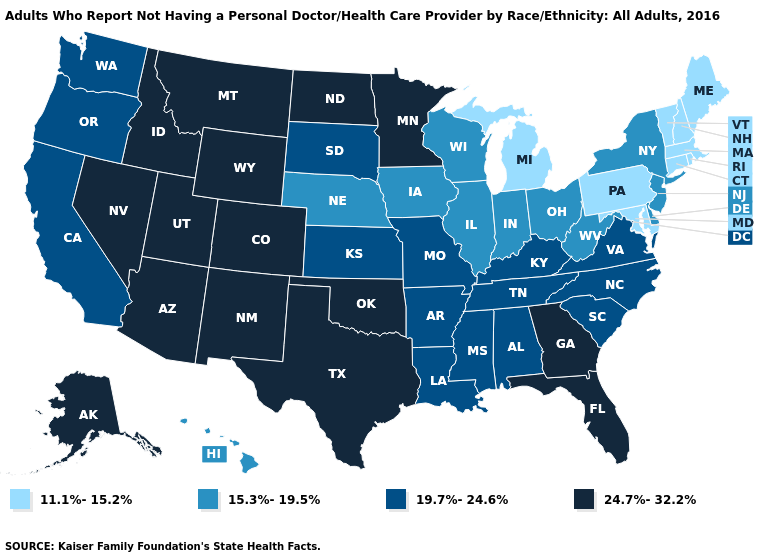Is the legend a continuous bar?
Concise answer only. No. What is the value of Texas?
Answer briefly. 24.7%-32.2%. Does Louisiana have the same value as North Carolina?
Keep it brief. Yes. What is the value of Michigan?
Quick response, please. 11.1%-15.2%. Does the map have missing data?
Quick response, please. No. What is the highest value in the MidWest ?
Keep it brief. 24.7%-32.2%. Does Oklahoma have the same value as North Carolina?
Write a very short answer. No. What is the highest value in states that border South Carolina?
Keep it brief. 24.7%-32.2%. Among the states that border New Hampshire , which have the lowest value?
Concise answer only. Maine, Massachusetts, Vermont. Name the states that have a value in the range 11.1%-15.2%?
Concise answer only. Connecticut, Maine, Maryland, Massachusetts, Michigan, New Hampshire, Pennsylvania, Rhode Island, Vermont. Among the states that border Alabama , does Tennessee have the lowest value?
Quick response, please. Yes. Among the states that border Louisiana , does Texas have the lowest value?
Quick response, please. No. What is the value of Oklahoma?
Quick response, please. 24.7%-32.2%. What is the value of Pennsylvania?
Be succinct. 11.1%-15.2%. 